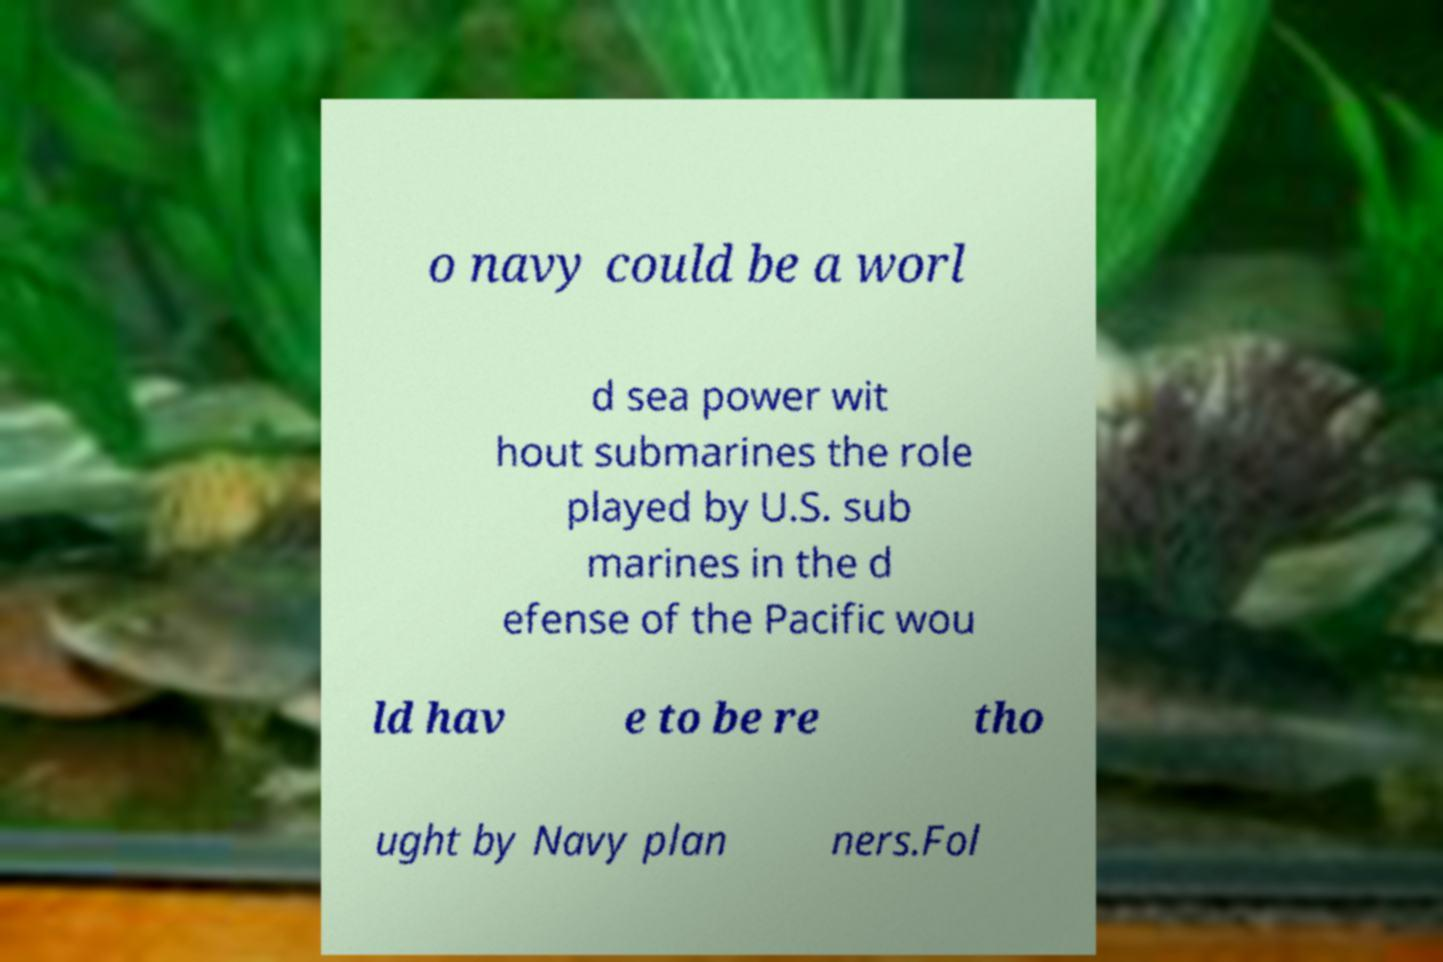Please read and relay the text visible in this image. What does it say? o navy could be a worl d sea power wit hout submarines the role played by U.S. sub marines in the d efense of the Pacific wou ld hav e to be re tho ught by Navy plan ners.Fol 